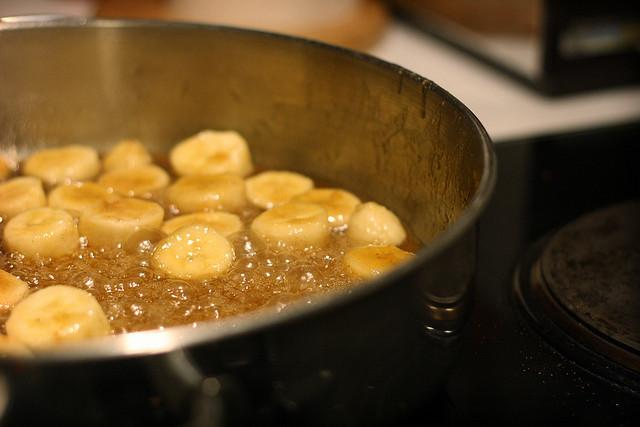What is this pan currently being used to create?

Choices:
A) entree
B) salad
C) appetizer
D) dessert dessert 